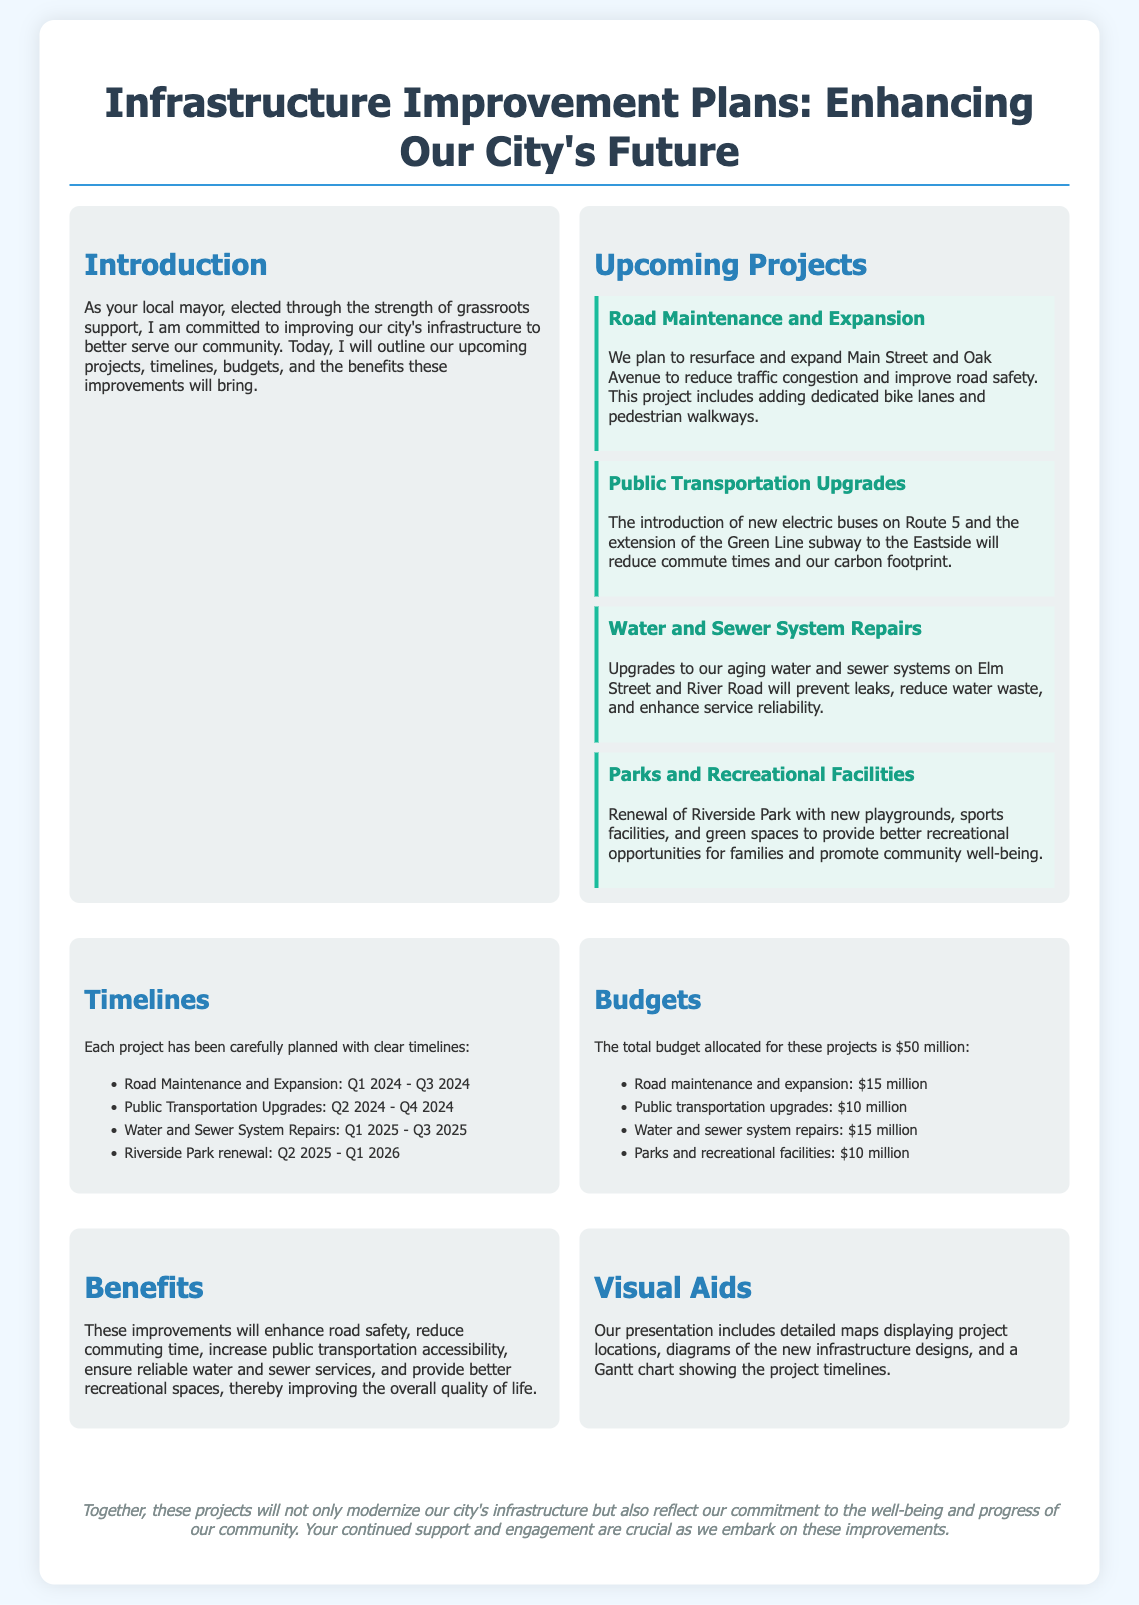What is the total budget allocated for the projects? The total budget indicated in the document is $50 million.
Answer: $50 million When will the Road Maintenance and Expansion project begin? The document states that this project will start in Q1 2024.
Answer: Q1 2024 What are the benefits of the infrastructure improvements? The document lists benefits such as enhancing road safety and increasing public transportation accessibility.
Answer: Enhance road safety and increase public transportation accessibility How much is allocated for Public Transportation Upgrades? The budget section specifies that $10 million is allocated for this project.
Answer: $10 million What is the end date for the Riverside Park renewal project? According to the timeline, this project will end in Q1 2026.
Answer: Q1 2026 Which street will have dedicated bike lanes added? The document mentions that bike lanes will be added to Main Street.
Answer: Main Street How long is the Water and Sewer System Repairs project scheduled to last? The project timeline shows it will take from Q1 2025 to Q3 2025, a total of about 2.5 years.
Answer: 2.5 years What type of new buses will be introduced on Route 5? The document highlights that new electric buses will be introduced.
Answer: Electric buses What visual aids are included in the presentation? The document states that the visual aids include detailed maps and diagrams of the new infrastructure designs.
Answer: Detailed maps and diagrams 